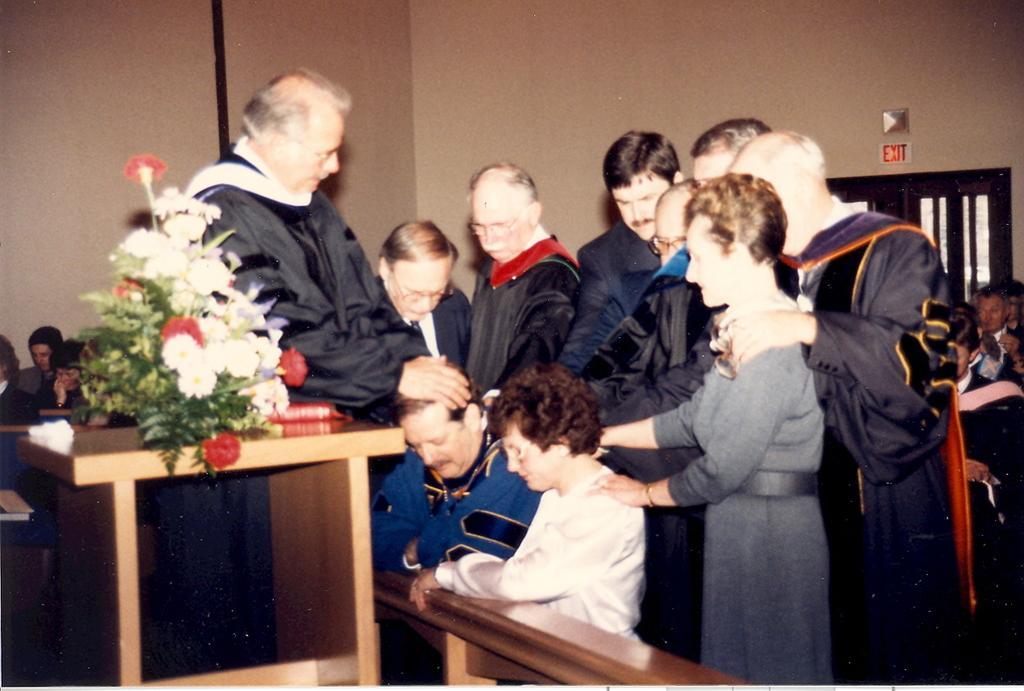How would you summarize this image in a sentence or two? This is an image clicked inside the room. Here I can see few people are standing and kept their hands on one person's head which is sitting on the floor. Beside this man there is another woman. In the background I can see few people are sitting on the chairs. On the left side there is a table on which a flower bouquet is placed. 